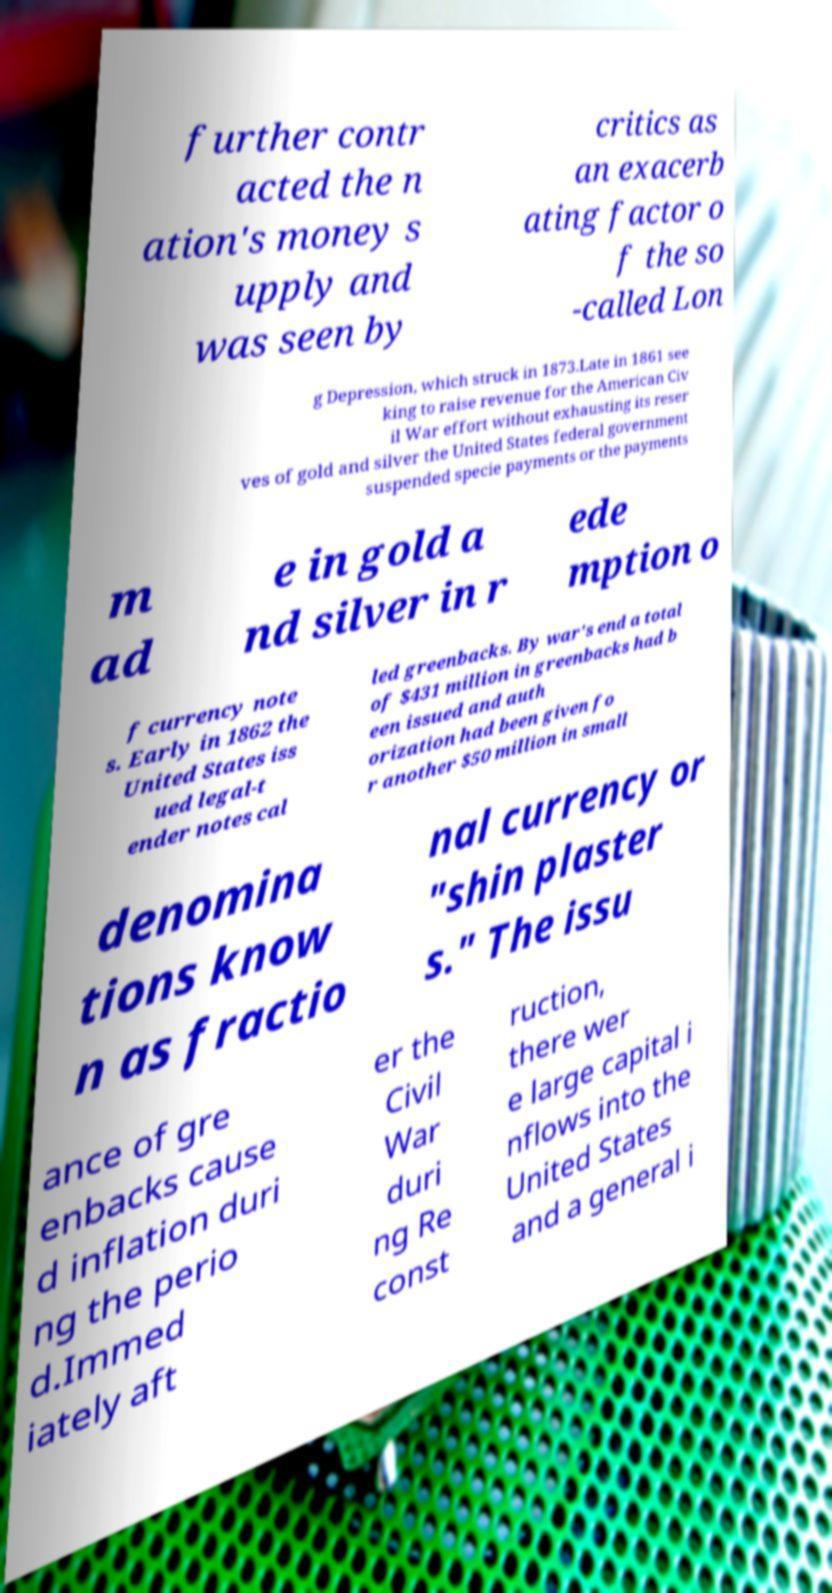Can you read and provide the text displayed in the image?This photo seems to have some interesting text. Can you extract and type it out for me? further contr acted the n ation's money s upply and was seen by critics as an exacerb ating factor o f the so -called Lon g Depression, which struck in 1873.Late in 1861 see king to raise revenue for the American Civ il War effort without exhausting its reser ves of gold and silver the United States federal government suspended specie payments or the payments m ad e in gold a nd silver in r ede mption o f currency note s. Early in 1862 the United States iss ued legal-t ender notes cal led greenbacks. By war's end a total of $431 million in greenbacks had b een issued and auth orization had been given fo r another $50 million in small denomina tions know n as fractio nal currency or "shin plaster s." The issu ance of gre enbacks cause d inflation duri ng the perio d.Immed iately aft er the Civil War duri ng Re const ruction, there wer e large capital i nflows into the United States and a general i 